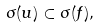<formula> <loc_0><loc_0><loc_500><loc_500>\sigma ( u ) \subset \sigma ( f ) ,</formula> 